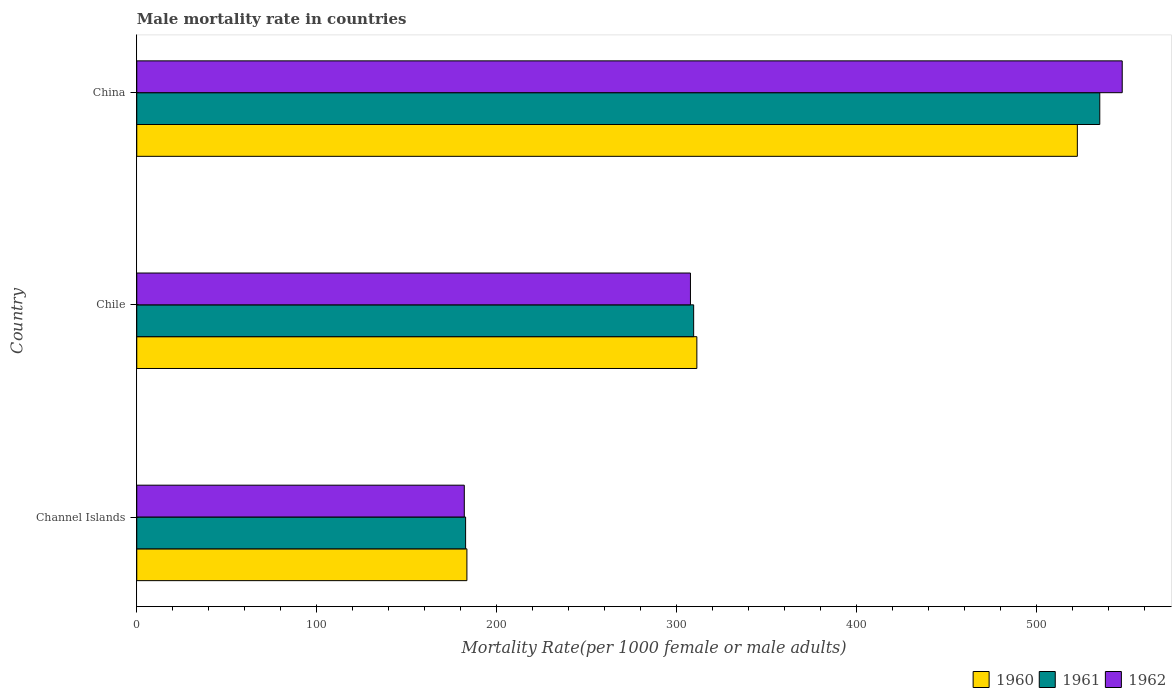How many different coloured bars are there?
Provide a short and direct response. 3. Are the number of bars per tick equal to the number of legend labels?
Give a very brief answer. Yes. How many bars are there on the 1st tick from the top?
Ensure brevity in your answer.  3. How many bars are there on the 2nd tick from the bottom?
Provide a short and direct response. 3. What is the label of the 3rd group of bars from the top?
Your answer should be compact. Channel Islands. In how many cases, is the number of bars for a given country not equal to the number of legend labels?
Keep it short and to the point. 0. What is the male mortality rate in 1961 in Channel Islands?
Your response must be concise. 182.65. Across all countries, what is the maximum male mortality rate in 1960?
Your answer should be compact. 522.44. Across all countries, what is the minimum male mortality rate in 1960?
Provide a succinct answer. 183.37. In which country was the male mortality rate in 1960 minimum?
Make the answer very short. Channel Islands. What is the total male mortality rate in 1962 in the graph?
Make the answer very short. 1036.85. What is the difference between the male mortality rate in 1960 in Chile and that in China?
Offer a terse response. -211.34. What is the difference between the male mortality rate in 1960 in China and the male mortality rate in 1962 in Channel Islands?
Give a very brief answer. 340.52. What is the average male mortality rate in 1960 per country?
Provide a short and direct response. 338.97. What is the difference between the male mortality rate in 1960 and male mortality rate in 1962 in China?
Make the answer very short. -24.93. In how many countries, is the male mortality rate in 1960 greater than 240 ?
Ensure brevity in your answer.  2. What is the ratio of the male mortality rate in 1961 in Chile to that in China?
Ensure brevity in your answer.  0.58. Is the male mortality rate in 1960 in Chile less than that in China?
Ensure brevity in your answer.  Yes. Is the difference between the male mortality rate in 1960 in Chile and China greater than the difference between the male mortality rate in 1962 in Chile and China?
Offer a very short reply. Yes. What is the difference between the highest and the second highest male mortality rate in 1961?
Ensure brevity in your answer.  225.58. What is the difference between the highest and the lowest male mortality rate in 1960?
Provide a short and direct response. 339.07. Is the sum of the male mortality rate in 1960 in Channel Islands and China greater than the maximum male mortality rate in 1962 across all countries?
Your response must be concise. Yes. What does the 1st bar from the bottom in Chile represents?
Your answer should be compact. 1960. How many countries are there in the graph?
Give a very brief answer. 3. Does the graph contain any zero values?
Provide a succinct answer. No. Does the graph contain grids?
Your answer should be compact. No. How many legend labels are there?
Your answer should be compact. 3. How are the legend labels stacked?
Provide a short and direct response. Horizontal. What is the title of the graph?
Offer a terse response. Male mortality rate in countries. What is the label or title of the X-axis?
Ensure brevity in your answer.  Mortality Rate(per 1000 female or male adults). What is the label or title of the Y-axis?
Provide a short and direct response. Country. What is the Mortality Rate(per 1000 female or male adults) of 1960 in Channel Islands?
Offer a terse response. 183.37. What is the Mortality Rate(per 1000 female or male adults) of 1961 in Channel Islands?
Keep it short and to the point. 182.65. What is the Mortality Rate(per 1000 female or male adults) of 1962 in Channel Islands?
Offer a very short reply. 181.93. What is the Mortality Rate(per 1000 female or male adults) in 1960 in Chile?
Your response must be concise. 311.11. What is the Mortality Rate(per 1000 female or male adults) in 1961 in Chile?
Make the answer very short. 309.33. What is the Mortality Rate(per 1000 female or male adults) in 1962 in Chile?
Your answer should be very brief. 307.55. What is the Mortality Rate(per 1000 female or male adults) of 1960 in China?
Offer a very short reply. 522.44. What is the Mortality Rate(per 1000 female or male adults) of 1961 in China?
Offer a terse response. 534.91. What is the Mortality Rate(per 1000 female or male adults) in 1962 in China?
Offer a terse response. 547.37. Across all countries, what is the maximum Mortality Rate(per 1000 female or male adults) of 1960?
Provide a short and direct response. 522.44. Across all countries, what is the maximum Mortality Rate(per 1000 female or male adults) in 1961?
Keep it short and to the point. 534.91. Across all countries, what is the maximum Mortality Rate(per 1000 female or male adults) in 1962?
Provide a short and direct response. 547.37. Across all countries, what is the minimum Mortality Rate(per 1000 female or male adults) of 1960?
Your answer should be compact. 183.37. Across all countries, what is the minimum Mortality Rate(per 1000 female or male adults) of 1961?
Your answer should be very brief. 182.65. Across all countries, what is the minimum Mortality Rate(per 1000 female or male adults) of 1962?
Your answer should be very brief. 181.93. What is the total Mortality Rate(per 1000 female or male adults) of 1960 in the graph?
Provide a succinct answer. 1016.92. What is the total Mortality Rate(per 1000 female or male adults) of 1961 in the graph?
Your response must be concise. 1026.88. What is the total Mortality Rate(per 1000 female or male adults) in 1962 in the graph?
Offer a very short reply. 1036.85. What is the difference between the Mortality Rate(per 1000 female or male adults) of 1960 in Channel Islands and that in Chile?
Ensure brevity in your answer.  -127.73. What is the difference between the Mortality Rate(per 1000 female or male adults) in 1961 in Channel Islands and that in Chile?
Offer a very short reply. -126.67. What is the difference between the Mortality Rate(per 1000 female or male adults) of 1962 in Channel Islands and that in Chile?
Your answer should be very brief. -125.62. What is the difference between the Mortality Rate(per 1000 female or male adults) in 1960 in Channel Islands and that in China?
Offer a very short reply. -339.07. What is the difference between the Mortality Rate(per 1000 female or male adults) of 1961 in Channel Islands and that in China?
Your answer should be very brief. -352.26. What is the difference between the Mortality Rate(per 1000 female or male adults) in 1962 in Channel Islands and that in China?
Offer a very short reply. -365.44. What is the difference between the Mortality Rate(per 1000 female or male adults) of 1960 in Chile and that in China?
Offer a very short reply. -211.34. What is the difference between the Mortality Rate(per 1000 female or male adults) of 1961 in Chile and that in China?
Provide a succinct answer. -225.58. What is the difference between the Mortality Rate(per 1000 female or male adults) of 1962 in Chile and that in China?
Offer a very short reply. -239.82. What is the difference between the Mortality Rate(per 1000 female or male adults) of 1960 in Channel Islands and the Mortality Rate(per 1000 female or male adults) of 1961 in Chile?
Keep it short and to the point. -125.95. What is the difference between the Mortality Rate(per 1000 female or male adults) in 1960 in Channel Islands and the Mortality Rate(per 1000 female or male adults) in 1962 in Chile?
Your response must be concise. -124.17. What is the difference between the Mortality Rate(per 1000 female or male adults) in 1961 in Channel Islands and the Mortality Rate(per 1000 female or male adults) in 1962 in Chile?
Offer a terse response. -124.9. What is the difference between the Mortality Rate(per 1000 female or male adults) of 1960 in Channel Islands and the Mortality Rate(per 1000 female or male adults) of 1961 in China?
Give a very brief answer. -351.53. What is the difference between the Mortality Rate(per 1000 female or male adults) in 1960 in Channel Islands and the Mortality Rate(per 1000 female or male adults) in 1962 in China?
Your response must be concise. -364. What is the difference between the Mortality Rate(per 1000 female or male adults) of 1961 in Channel Islands and the Mortality Rate(per 1000 female or male adults) of 1962 in China?
Make the answer very short. -364.72. What is the difference between the Mortality Rate(per 1000 female or male adults) of 1960 in Chile and the Mortality Rate(per 1000 female or male adults) of 1961 in China?
Give a very brief answer. -223.8. What is the difference between the Mortality Rate(per 1000 female or male adults) in 1960 in Chile and the Mortality Rate(per 1000 female or male adults) in 1962 in China?
Provide a short and direct response. -236.27. What is the difference between the Mortality Rate(per 1000 female or male adults) of 1961 in Chile and the Mortality Rate(per 1000 female or male adults) of 1962 in China?
Your answer should be very brief. -238.05. What is the average Mortality Rate(per 1000 female or male adults) in 1960 per country?
Offer a very short reply. 338.97. What is the average Mortality Rate(per 1000 female or male adults) in 1961 per country?
Your answer should be compact. 342.29. What is the average Mortality Rate(per 1000 female or male adults) of 1962 per country?
Your answer should be very brief. 345.62. What is the difference between the Mortality Rate(per 1000 female or male adults) in 1960 and Mortality Rate(per 1000 female or male adults) in 1961 in Channel Islands?
Keep it short and to the point. 0.72. What is the difference between the Mortality Rate(per 1000 female or male adults) in 1960 and Mortality Rate(per 1000 female or male adults) in 1962 in Channel Islands?
Provide a succinct answer. 1.45. What is the difference between the Mortality Rate(per 1000 female or male adults) in 1961 and Mortality Rate(per 1000 female or male adults) in 1962 in Channel Islands?
Your answer should be compact. 0.72. What is the difference between the Mortality Rate(per 1000 female or male adults) in 1960 and Mortality Rate(per 1000 female or male adults) in 1961 in Chile?
Provide a succinct answer. 1.78. What is the difference between the Mortality Rate(per 1000 female or male adults) of 1960 and Mortality Rate(per 1000 female or male adults) of 1962 in Chile?
Provide a short and direct response. 3.56. What is the difference between the Mortality Rate(per 1000 female or male adults) in 1961 and Mortality Rate(per 1000 female or male adults) in 1962 in Chile?
Provide a succinct answer. 1.78. What is the difference between the Mortality Rate(per 1000 female or male adults) of 1960 and Mortality Rate(per 1000 female or male adults) of 1961 in China?
Your response must be concise. -12.46. What is the difference between the Mortality Rate(per 1000 female or male adults) in 1960 and Mortality Rate(per 1000 female or male adults) in 1962 in China?
Your answer should be very brief. -24.93. What is the difference between the Mortality Rate(per 1000 female or male adults) of 1961 and Mortality Rate(per 1000 female or male adults) of 1962 in China?
Offer a terse response. -12.46. What is the ratio of the Mortality Rate(per 1000 female or male adults) in 1960 in Channel Islands to that in Chile?
Provide a succinct answer. 0.59. What is the ratio of the Mortality Rate(per 1000 female or male adults) in 1961 in Channel Islands to that in Chile?
Make the answer very short. 0.59. What is the ratio of the Mortality Rate(per 1000 female or male adults) of 1962 in Channel Islands to that in Chile?
Your answer should be compact. 0.59. What is the ratio of the Mortality Rate(per 1000 female or male adults) in 1960 in Channel Islands to that in China?
Give a very brief answer. 0.35. What is the ratio of the Mortality Rate(per 1000 female or male adults) in 1961 in Channel Islands to that in China?
Provide a succinct answer. 0.34. What is the ratio of the Mortality Rate(per 1000 female or male adults) of 1962 in Channel Islands to that in China?
Ensure brevity in your answer.  0.33. What is the ratio of the Mortality Rate(per 1000 female or male adults) of 1960 in Chile to that in China?
Make the answer very short. 0.6. What is the ratio of the Mortality Rate(per 1000 female or male adults) in 1961 in Chile to that in China?
Provide a short and direct response. 0.58. What is the ratio of the Mortality Rate(per 1000 female or male adults) in 1962 in Chile to that in China?
Ensure brevity in your answer.  0.56. What is the difference between the highest and the second highest Mortality Rate(per 1000 female or male adults) in 1960?
Offer a terse response. 211.34. What is the difference between the highest and the second highest Mortality Rate(per 1000 female or male adults) of 1961?
Your response must be concise. 225.58. What is the difference between the highest and the second highest Mortality Rate(per 1000 female or male adults) in 1962?
Provide a succinct answer. 239.82. What is the difference between the highest and the lowest Mortality Rate(per 1000 female or male adults) of 1960?
Offer a very short reply. 339.07. What is the difference between the highest and the lowest Mortality Rate(per 1000 female or male adults) of 1961?
Keep it short and to the point. 352.26. What is the difference between the highest and the lowest Mortality Rate(per 1000 female or male adults) in 1962?
Offer a terse response. 365.44. 